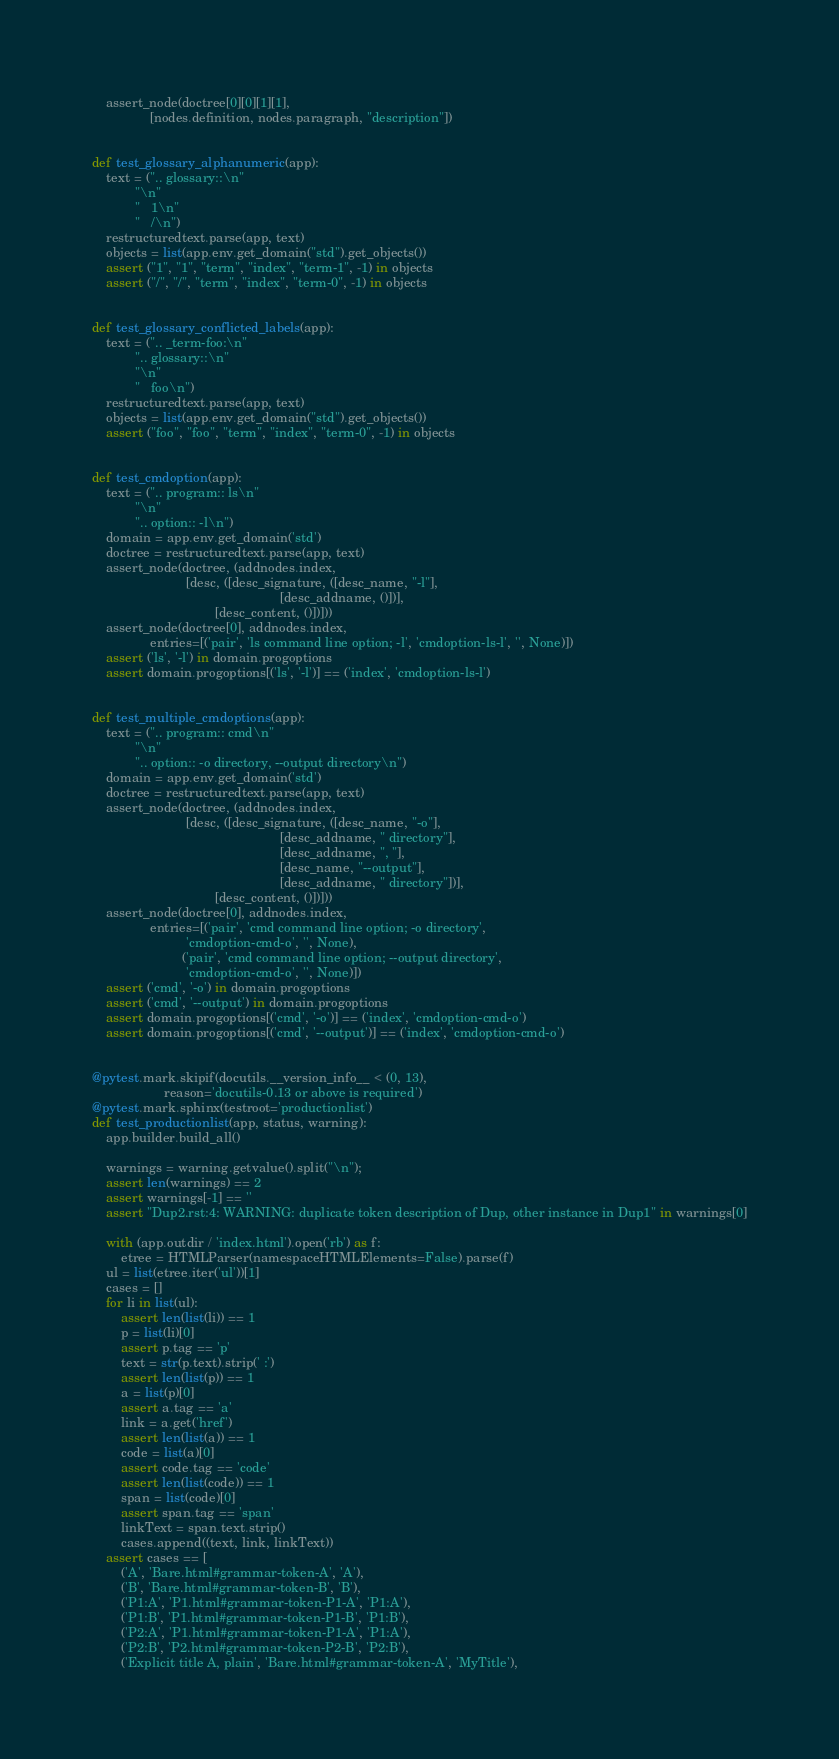Convert code to text. <code><loc_0><loc_0><loc_500><loc_500><_Python_>    assert_node(doctree[0][0][1][1],
                [nodes.definition, nodes.paragraph, "description"])


def test_glossary_alphanumeric(app):
    text = (".. glossary::\n"
            "\n"
            "   1\n"
            "   /\n")
    restructuredtext.parse(app, text)
    objects = list(app.env.get_domain("std").get_objects())
    assert ("1", "1", "term", "index", "term-1", -1) in objects
    assert ("/", "/", "term", "index", "term-0", -1) in objects


def test_glossary_conflicted_labels(app):
    text = (".. _term-foo:\n"
            ".. glossary::\n"
            "\n"
            "   foo\n")
    restructuredtext.parse(app, text)
    objects = list(app.env.get_domain("std").get_objects())
    assert ("foo", "foo", "term", "index", "term-0", -1) in objects


def test_cmdoption(app):
    text = (".. program:: ls\n"
            "\n"
            ".. option:: -l\n")
    domain = app.env.get_domain('std')
    doctree = restructuredtext.parse(app, text)
    assert_node(doctree, (addnodes.index,
                          [desc, ([desc_signature, ([desc_name, "-l"],
                                                    [desc_addname, ()])],
                                  [desc_content, ()])]))
    assert_node(doctree[0], addnodes.index,
                entries=[('pair', 'ls command line option; -l', 'cmdoption-ls-l', '', None)])
    assert ('ls', '-l') in domain.progoptions
    assert domain.progoptions[('ls', '-l')] == ('index', 'cmdoption-ls-l')


def test_multiple_cmdoptions(app):
    text = (".. program:: cmd\n"
            "\n"
            ".. option:: -o directory, --output directory\n")
    domain = app.env.get_domain('std')
    doctree = restructuredtext.parse(app, text)
    assert_node(doctree, (addnodes.index,
                          [desc, ([desc_signature, ([desc_name, "-o"],
                                                    [desc_addname, " directory"],
                                                    [desc_addname, ", "],
                                                    [desc_name, "--output"],
                                                    [desc_addname, " directory"])],
                                  [desc_content, ()])]))
    assert_node(doctree[0], addnodes.index,
                entries=[('pair', 'cmd command line option; -o directory',
                          'cmdoption-cmd-o', '', None),
                         ('pair', 'cmd command line option; --output directory',
                          'cmdoption-cmd-o', '', None)])
    assert ('cmd', '-o') in domain.progoptions
    assert ('cmd', '--output') in domain.progoptions
    assert domain.progoptions[('cmd', '-o')] == ('index', 'cmdoption-cmd-o')
    assert domain.progoptions[('cmd', '--output')] == ('index', 'cmdoption-cmd-o')


@pytest.mark.skipif(docutils.__version_info__ < (0, 13),
                    reason='docutils-0.13 or above is required')
@pytest.mark.sphinx(testroot='productionlist')
def test_productionlist(app, status, warning):
    app.builder.build_all()

    warnings = warning.getvalue().split("\n");
    assert len(warnings) == 2
    assert warnings[-1] == ''
    assert "Dup2.rst:4: WARNING: duplicate token description of Dup, other instance in Dup1" in warnings[0]

    with (app.outdir / 'index.html').open('rb') as f:
        etree = HTMLParser(namespaceHTMLElements=False).parse(f)
    ul = list(etree.iter('ul'))[1]
    cases = []
    for li in list(ul):
        assert len(list(li)) == 1
        p = list(li)[0]
        assert p.tag == 'p'
        text = str(p.text).strip(' :')
        assert len(list(p)) == 1
        a = list(p)[0]
        assert a.tag == 'a'
        link = a.get('href')
        assert len(list(a)) == 1
        code = list(a)[0]
        assert code.tag == 'code'
        assert len(list(code)) == 1
        span = list(code)[0]
        assert span.tag == 'span'
        linkText = span.text.strip()
        cases.append((text, link, linkText))
    assert cases == [
        ('A', 'Bare.html#grammar-token-A', 'A'),
        ('B', 'Bare.html#grammar-token-B', 'B'),
        ('P1:A', 'P1.html#grammar-token-P1-A', 'P1:A'),
        ('P1:B', 'P1.html#grammar-token-P1-B', 'P1:B'),
        ('P2:A', 'P1.html#grammar-token-P1-A', 'P1:A'),
        ('P2:B', 'P2.html#grammar-token-P2-B', 'P2:B'),
        ('Explicit title A, plain', 'Bare.html#grammar-token-A', 'MyTitle'),</code> 